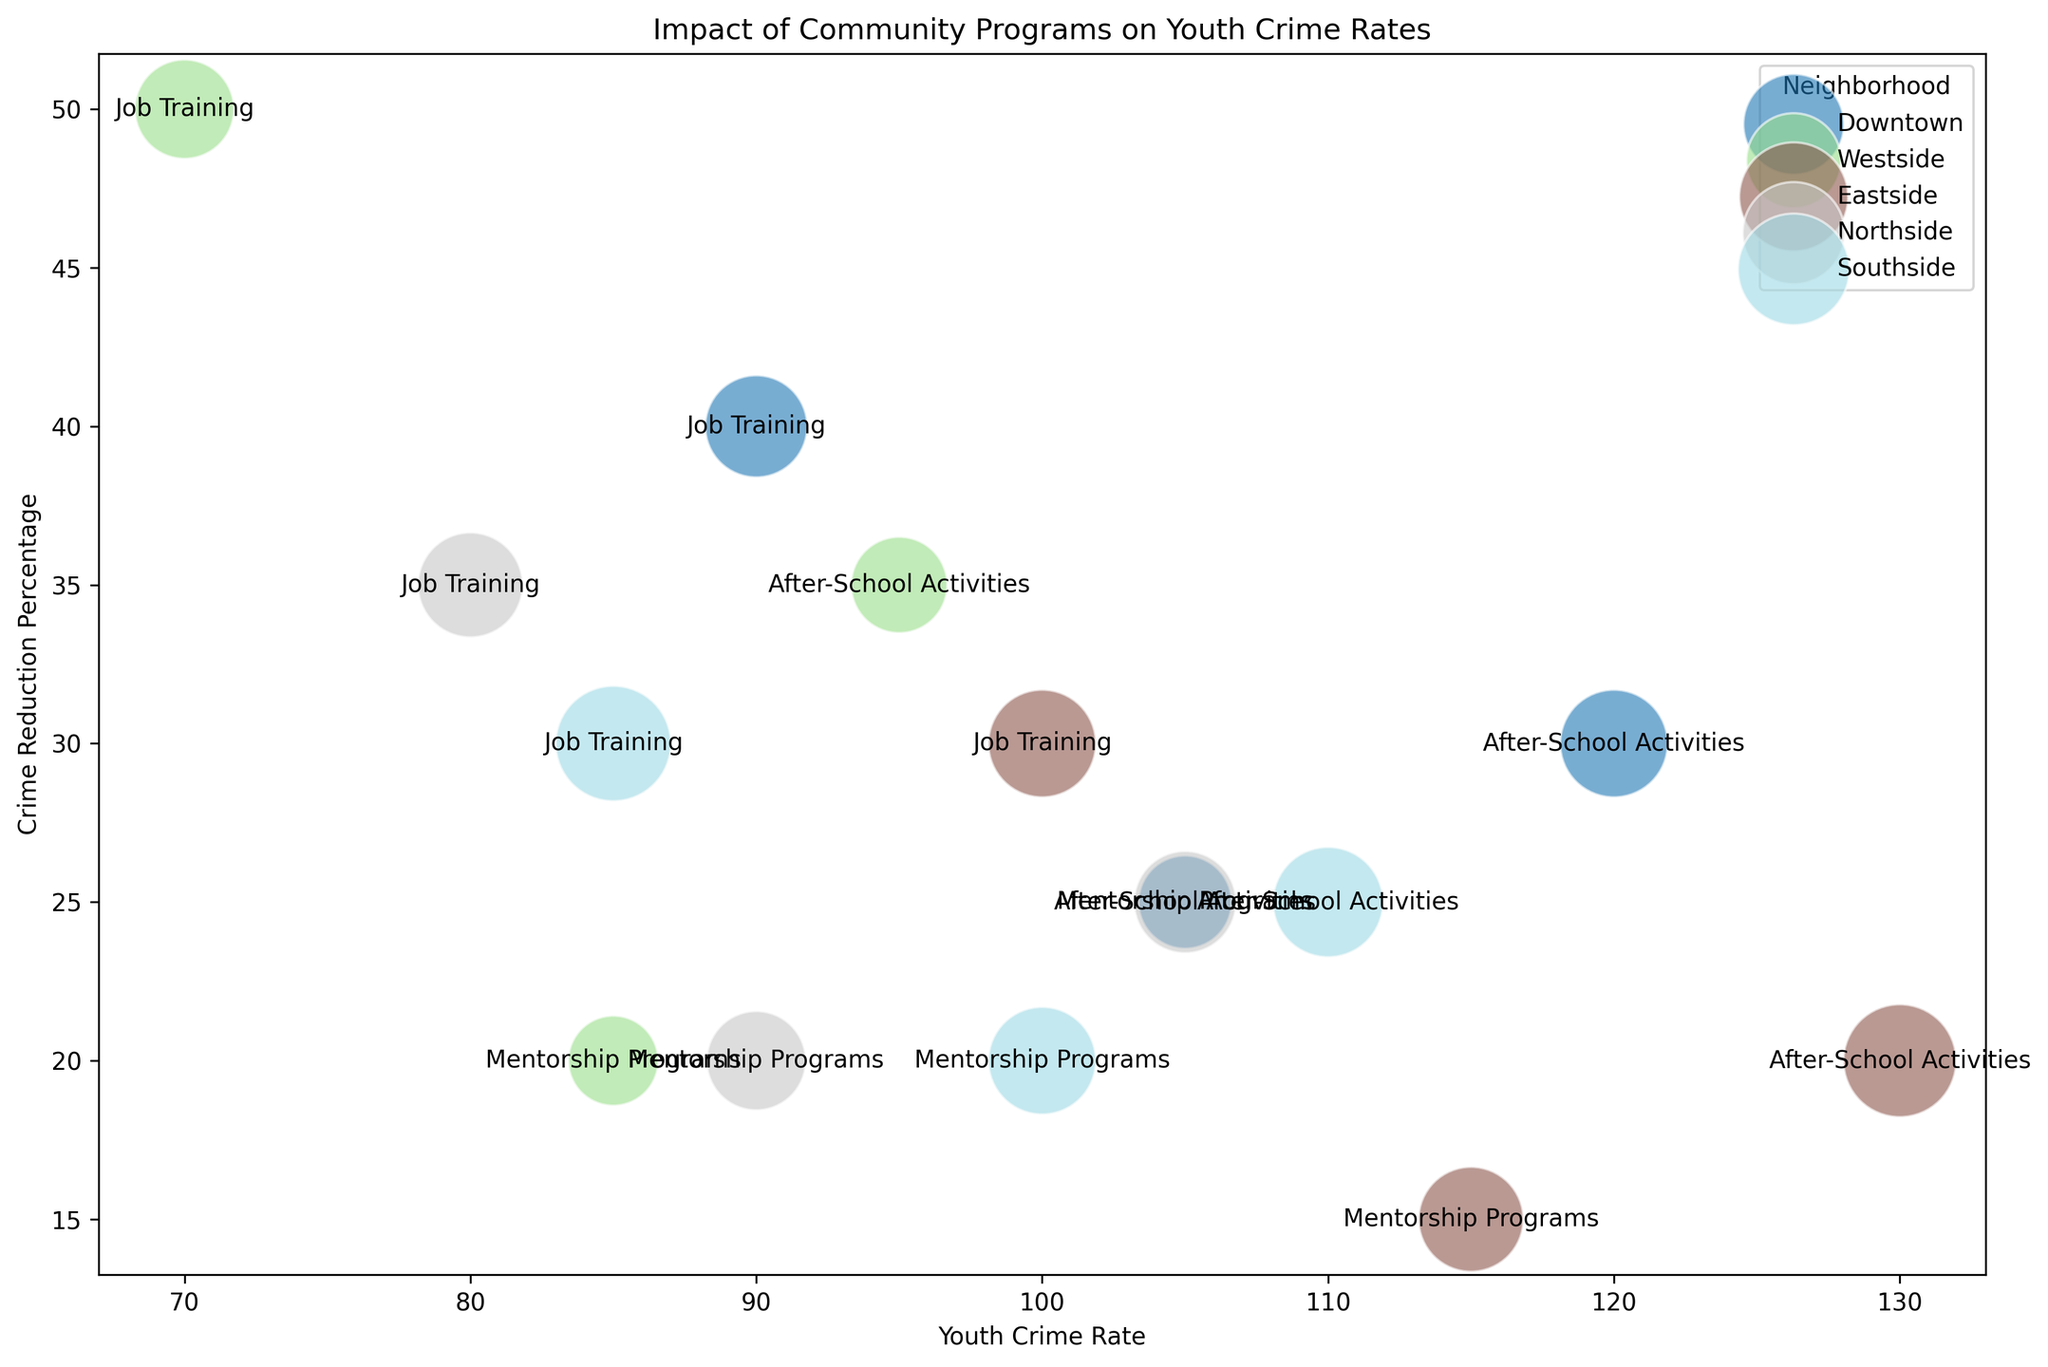What neighborhood has the highest crime reduction percentage for Job Training programs? Look at the points labeled "Job Training" and compare their crime reduction percentages. The highest value is in the Westside neighborhood with 50%.
Answer: Westside Which neighborhood's After-School Activities have the lowest crime reduction percentage? Look at the points labeled "After-School Activities" and compare their crime reduction percentages. The lowest value is in the Eastside neighborhood with 20%.
Answer: Eastside Compared to other neighborhoods, how well do Mentorship Programs reduce crime in the Downtown area? Look at the points labeled "Mentorship Programs" and compare the crime reduction percentages. Downtown has a 25% reduction, which is higher than Eastside (15%) but lower than Northside (20%) and Westside (20%).
Answer: Moderate, better than Eastside but worse than Northside and Westside What is the range of youth crime rates for neighborhoods with Job Training programs? Look at the points labeled "Job Training" and identify the minimum and maximum youth crime rates. The values range from 70 (Westside) to 100 (Eastside) to 90 (Downtown).
Answer: 70 to 100 Which program in the Northside neighborhood has the highest youth crime rate? Compare the youth crime rates for programs in the Northside neighborhood. The highest value is for After-School Activities with a rate of 105.
Answer: After-School Activities What is the average crime reduction percentage across all program types in the Westside neighborhood? Sum the crime reduction percentages for all programs in Westside (35% + 20% + 50%) and divide by the number of programs (3). (35 + 20 + 50) / 3 = 35%.
Answer: 35 How does job training in Downtown compare to job training in Southside in terms of crime reduction? Compare the crime reduction percentages for points labeled "Job Training" in Downtown (40%) and Southside (30%). Downtown has a higher reduction.
Answer: Downtown's 40% is higher than Southside's 30% What is the total number of youth participating in programs in the Eastside neighborhood? Sum the program participation numbers for the Eastside neighborhood (220 + 190 + 200). 220 + 190 + 200 = 610.
Answer: 610 Which neighborhood has the highest youth crime rate for After-School Activities and what is that rate? Compare the youth crime rates for points labeled "After-School Activities". The highest rate is in the Eastside neighborhood with a rate of 130.
Answer: Eastside with 130 